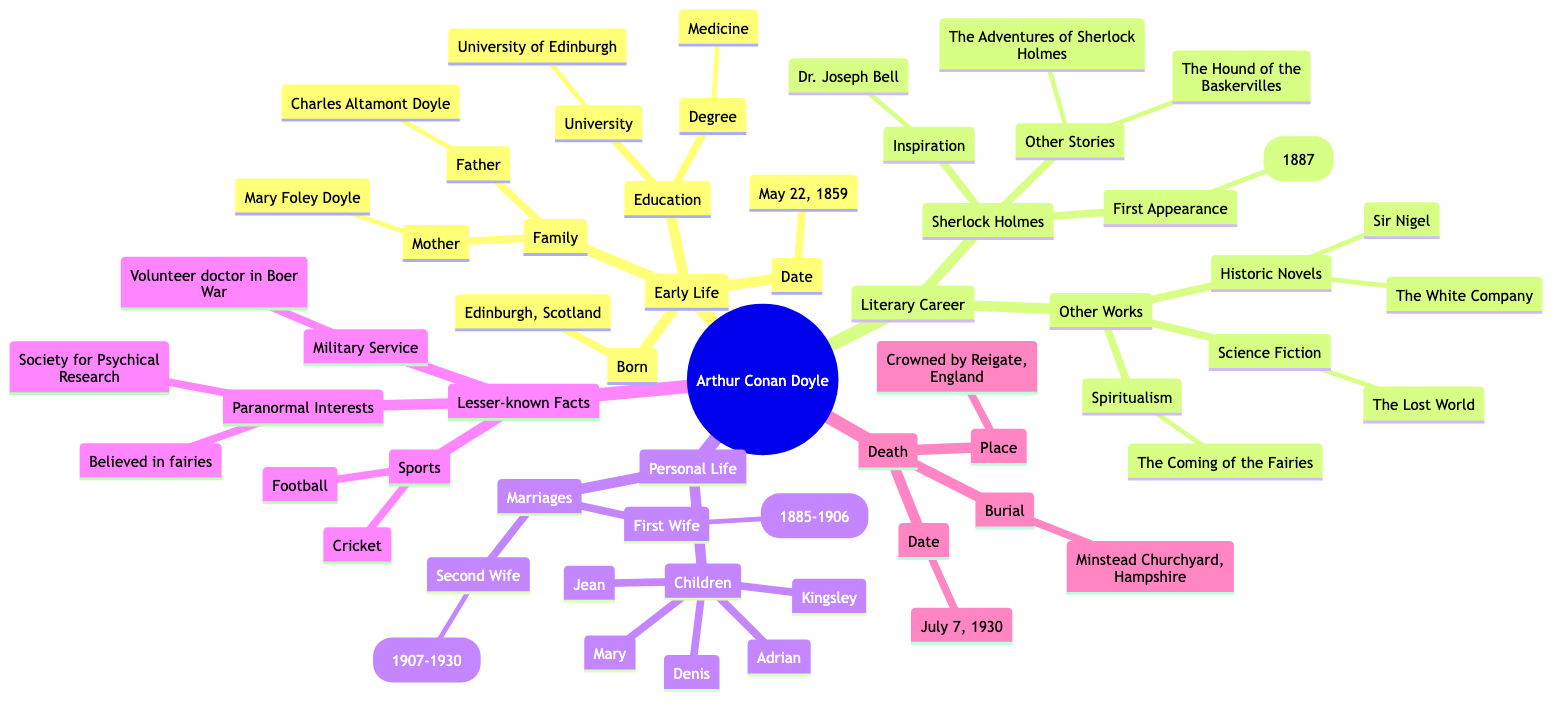What was Arthur Conan Doyle's date of birth? The diagram specifies that Arthur Conan Doyle was born on May 22, 1859, which is indicated under the "Early Life" section.
Answer: May 22, 1859 Who was Arthur Conan Doyle's first wife? According to the "Personal Life" section of the diagram, Arthur Conan Doyle's first wife was Louisa Hawkins.
Answer: Louisa Hawkins In which university did Arthur Conan Doyle study? In the "Education" part of the "Early Life" section, it is noted that he attended the University of Edinburgh.
Answer: University of Edinburgh How many children did Arthur Conan Doyle have? The diagram lists five children in the "Children" section under "Personal Life." Counting each name, we find that he had five children in total.
Answer: Five What was the inspiration behind Sherlock Holmes? The diagram states in the "Sherlock Holmes" subsection that Dr. Joseph Bell inspired the character of Sherlock Holmes.
Answer: Dr. Joseph Bell Which military conflict did Arthur Conan Doyle serve in as a doctor? The "Lesser-known Facts" section mentions that he served as a volunteer doctor in the Boer War, identifying the military conflict he participated in.
Answer: Boer War What type of writings did Arthur Conan Doyle create aside from Sherlock Holmes? The "Other Works" section indicates that he wrote historic novels, science fiction, and spiritualism works, showing the variety of his literary contributions beyond Sherlock Holmes.
Answer: Historic novels, science fiction, spiritualism Where is Arthur Conan Doyle buried? The "Burial" information in the "Death" section shows that he is buried in Minstead Churchyard, New Forest, Hampshire.
Answer: Minstead Churchyard, New Forest, Hampshire What is a lesser-known interest of Arthur Conan Doyle mentioned in the diagram? The "Lesser-known Facts" section reveals various interests, and one specific lesser-known interest mentioned is his belief in fairies, showcasing a unique aspect of his personality.
Answer: Believed in fairies 